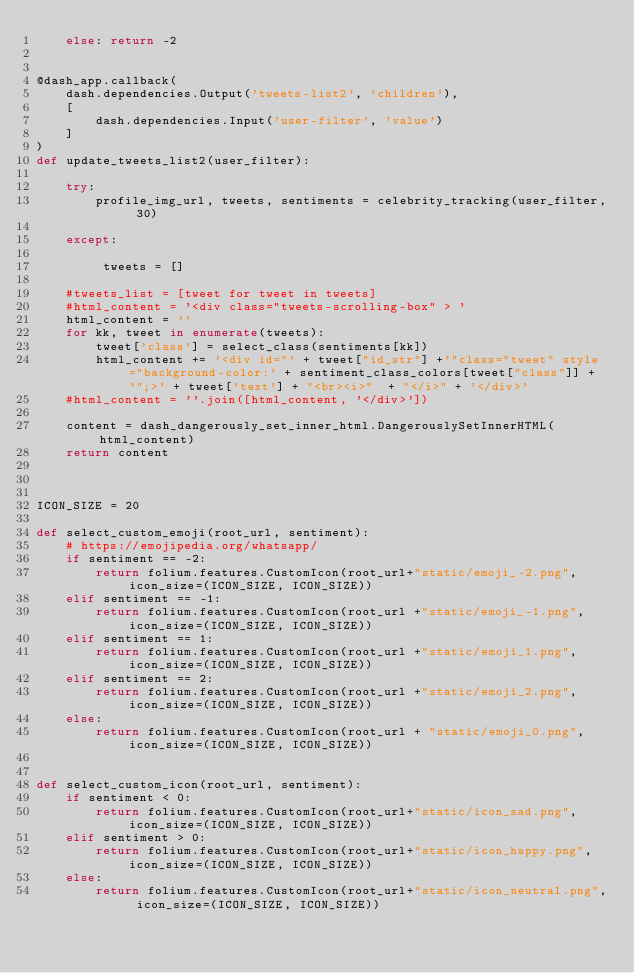Convert code to text. <code><loc_0><loc_0><loc_500><loc_500><_Python_>    else: return -2


@dash_app.callback(
    dash.dependencies.Output('tweets-list2', 'children'),
    [
        dash.dependencies.Input('user-filter', 'value')
    ]
)
def update_tweets_list2(user_filter):

    try:
        profile_img_url, tweets, sentiments = celebrity_tracking(user_filter, 30)

    except:

         tweets = []

    #tweets_list = [tweet for tweet in tweets]
    #html_content = '<div class="tweets-scrolling-box" > '
    html_content = ''
    for kk, tweet in enumerate(tweets):
        tweet['class'] = select_class(sentiments[kk])
        html_content += '<div id="' + tweet["id_str"] +'"class="tweet" style="background-color:' + sentiment_class_colors[tweet["class"]] + '";>' + tweet['text'] + "<br><i>"  + "</i>" + '</div>'
    #html_content = ''.join([html_content, '</div>'])

    content = dash_dangerously_set_inner_html.DangerouslySetInnerHTML(html_content)
    return content



ICON_SIZE = 20

def select_custom_emoji(root_url, sentiment):
    # https://emojipedia.org/whatsapp/
    if sentiment == -2:
        return folium.features.CustomIcon(root_url+"static/emoji_-2.png", icon_size=(ICON_SIZE, ICON_SIZE))
    elif sentiment == -1:
        return folium.features.CustomIcon(root_url +"static/emoji_-1.png", icon_size=(ICON_SIZE, ICON_SIZE))
    elif sentiment == 1:
        return folium.features.CustomIcon(root_url +"static/emoji_1.png", icon_size=(ICON_SIZE, ICON_SIZE))
    elif sentiment == 2:
        return folium.features.CustomIcon(root_url +"static/emoji_2.png", icon_size=(ICON_SIZE, ICON_SIZE))
    else:
        return folium.features.CustomIcon(root_url + "static/emoji_0.png", icon_size=(ICON_SIZE, ICON_SIZE))


def select_custom_icon(root_url, sentiment):
    if sentiment < 0:
        return folium.features.CustomIcon(root_url+"static/icon_sad.png", icon_size=(ICON_SIZE, ICON_SIZE))
    elif sentiment > 0:
        return folium.features.CustomIcon(root_url+"static/icon_happy.png", icon_size=(ICON_SIZE, ICON_SIZE))
    else:
        return folium.features.CustomIcon(root_url+"static/icon_neutral.png", icon_size=(ICON_SIZE, ICON_SIZE))

</code> 